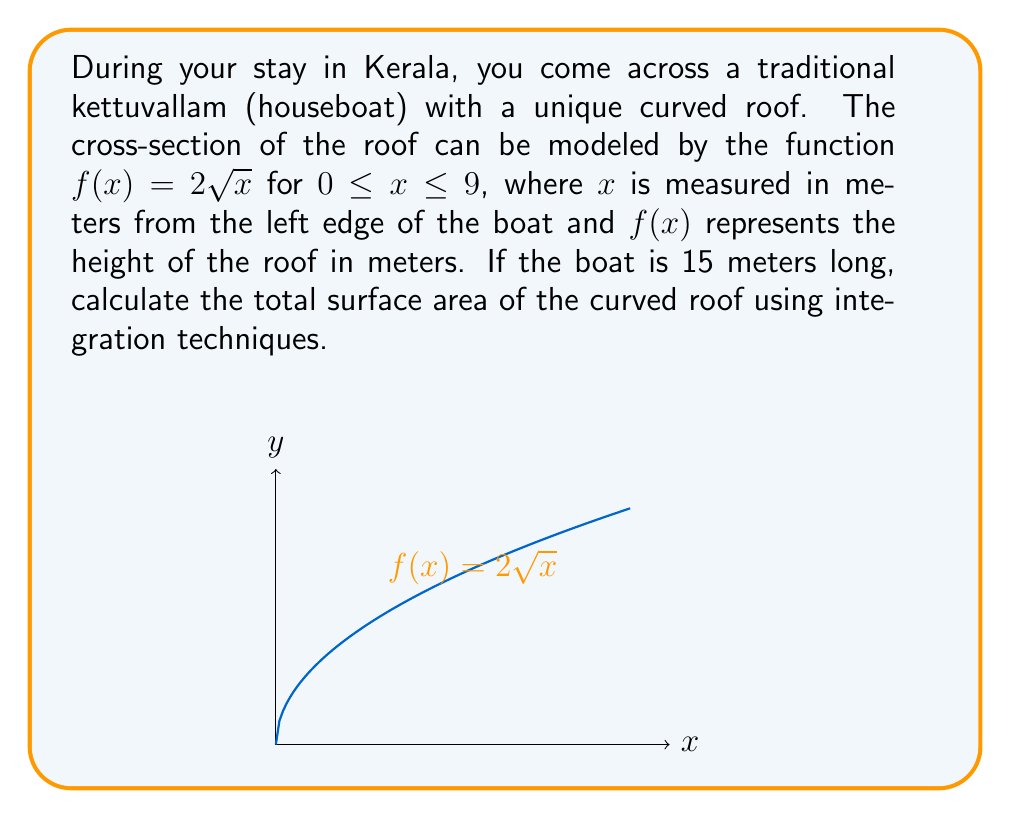Teach me how to tackle this problem. To find the surface area of the curved roof, we need to use the formula for the surface area of a surface of revolution:

$$A = 2\pi \int_{a}^{b} f(x) \sqrt{1 + [f'(x)]^2} dx$$

Here, we're not revolving around an axis, but the concept is similar. We'll use the length of the boat instead of $2\pi$.

Steps:
1) First, find $f'(x)$:
   $f(x) = 2\sqrt{x}$
   $f'(x) = \frac{1}{\sqrt{x}}$

2) Calculate $1 + [f'(x)]^2$:
   $1 + [f'(x)]^2 = 1 + (\frac{1}{\sqrt{x}})^2 = 1 + \frac{1}{x} = \frac{x+1}{x}$

3) Set up the integral:
   $A = 15 \int_{0}^{9} 2\sqrt{x} \sqrt{\frac{x+1}{x}} dx$

4) Simplify the integrand:
   $A = 15 \int_{0}^{9} 2\sqrt{x} \sqrt{\frac{x+1}{x}} dx = 15 \int_{0}^{9} 2\sqrt{x+1} dx$

5) Substitute $u = x+1$, $du = dx$:
   $A = 15 \int_{1}^{10} 2\sqrt{u} du$

6) Integrate:
   $A = 15 \cdot 2 \cdot \frac{2}{3}u^{3/2}\Big|_{1}^{10} = 20(10^{3/2} - 1)$

7) Calculate the final result:
   $A = 20(31.6227766 - 1) = 612.4555320$ square meters
Answer: $612.46$ m² 